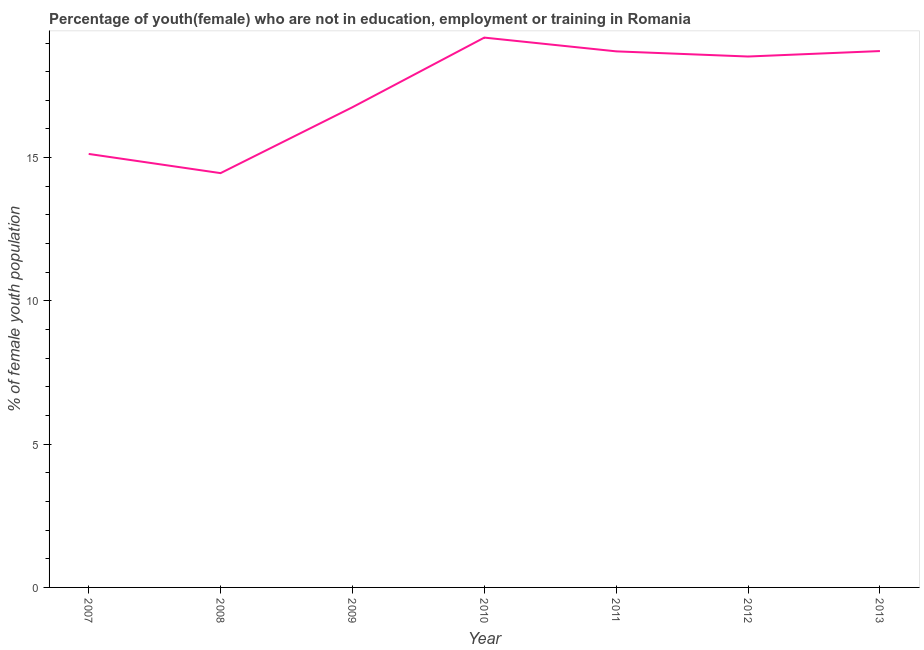What is the unemployed female youth population in 2008?
Make the answer very short. 14.46. Across all years, what is the maximum unemployed female youth population?
Provide a succinct answer. 19.19. Across all years, what is the minimum unemployed female youth population?
Your answer should be compact. 14.46. In which year was the unemployed female youth population maximum?
Your answer should be compact. 2010. What is the sum of the unemployed female youth population?
Your answer should be very brief. 121.5. What is the difference between the unemployed female youth population in 2007 and 2011?
Offer a terse response. -3.58. What is the average unemployed female youth population per year?
Your answer should be very brief. 17.36. What is the median unemployed female youth population?
Offer a very short reply. 18.53. What is the ratio of the unemployed female youth population in 2007 to that in 2009?
Your answer should be compact. 0.9. What is the difference between the highest and the second highest unemployed female youth population?
Give a very brief answer. 0.47. Is the sum of the unemployed female youth population in 2009 and 2011 greater than the maximum unemployed female youth population across all years?
Offer a very short reply. Yes. What is the difference between the highest and the lowest unemployed female youth population?
Keep it short and to the point. 4.73. Does the unemployed female youth population monotonically increase over the years?
Your response must be concise. No. How many years are there in the graph?
Provide a succinct answer. 7. Does the graph contain any zero values?
Provide a short and direct response. No. What is the title of the graph?
Offer a very short reply. Percentage of youth(female) who are not in education, employment or training in Romania. What is the label or title of the X-axis?
Provide a short and direct response. Year. What is the label or title of the Y-axis?
Ensure brevity in your answer.  % of female youth population. What is the % of female youth population of 2007?
Keep it short and to the point. 15.13. What is the % of female youth population of 2008?
Provide a short and direct response. 14.46. What is the % of female youth population of 2009?
Ensure brevity in your answer.  16.76. What is the % of female youth population in 2010?
Provide a succinct answer. 19.19. What is the % of female youth population in 2011?
Make the answer very short. 18.71. What is the % of female youth population of 2012?
Your answer should be compact. 18.53. What is the % of female youth population of 2013?
Make the answer very short. 18.72. What is the difference between the % of female youth population in 2007 and 2008?
Offer a terse response. 0.67. What is the difference between the % of female youth population in 2007 and 2009?
Make the answer very short. -1.63. What is the difference between the % of female youth population in 2007 and 2010?
Provide a short and direct response. -4.06. What is the difference between the % of female youth population in 2007 and 2011?
Your answer should be compact. -3.58. What is the difference between the % of female youth population in 2007 and 2012?
Give a very brief answer. -3.4. What is the difference between the % of female youth population in 2007 and 2013?
Your response must be concise. -3.59. What is the difference between the % of female youth population in 2008 and 2010?
Keep it short and to the point. -4.73. What is the difference between the % of female youth population in 2008 and 2011?
Make the answer very short. -4.25. What is the difference between the % of female youth population in 2008 and 2012?
Make the answer very short. -4.07. What is the difference between the % of female youth population in 2008 and 2013?
Make the answer very short. -4.26. What is the difference between the % of female youth population in 2009 and 2010?
Your answer should be very brief. -2.43. What is the difference between the % of female youth population in 2009 and 2011?
Provide a short and direct response. -1.95. What is the difference between the % of female youth population in 2009 and 2012?
Give a very brief answer. -1.77. What is the difference between the % of female youth population in 2009 and 2013?
Your answer should be compact. -1.96. What is the difference between the % of female youth population in 2010 and 2011?
Your answer should be very brief. 0.48. What is the difference between the % of female youth population in 2010 and 2012?
Give a very brief answer. 0.66. What is the difference between the % of female youth population in 2010 and 2013?
Provide a short and direct response. 0.47. What is the difference between the % of female youth population in 2011 and 2012?
Your answer should be very brief. 0.18. What is the difference between the % of female youth population in 2011 and 2013?
Your answer should be compact. -0.01. What is the difference between the % of female youth population in 2012 and 2013?
Offer a terse response. -0.19. What is the ratio of the % of female youth population in 2007 to that in 2008?
Your answer should be very brief. 1.05. What is the ratio of the % of female youth population in 2007 to that in 2009?
Provide a succinct answer. 0.9. What is the ratio of the % of female youth population in 2007 to that in 2010?
Your answer should be compact. 0.79. What is the ratio of the % of female youth population in 2007 to that in 2011?
Your response must be concise. 0.81. What is the ratio of the % of female youth population in 2007 to that in 2012?
Make the answer very short. 0.82. What is the ratio of the % of female youth population in 2007 to that in 2013?
Make the answer very short. 0.81. What is the ratio of the % of female youth population in 2008 to that in 2009?
Your answer should be compact. 0.86. What is the ratio of the % of female youth population in 2008 to that in 2010?
Give a very brief answer. 0.75. What is the ratio of the % of female youth population in 2008 to that in 2011?
Your answer should be very brief. 0.77. What is the ratio of the % of female youth population in 2008 to that in 2012?
Offer a terse response. 0.78. What is the ratio of the % of female youth population in 2008 to that in 2013?
Provide a succinct answer. 0.77. What is the ratio of the % of female youth population in 2009 to that in 2010?
Offer a terse response. 0.87. What is the ratio of the % of female youth population in 2009 to that in 2011?
Give a very brief answer. 0.9. What is the ratio of the % of female youth population in 2009 to that in 2012?
Your answer should be compact. 0.9. What is the ratio of the % of female youth population in 2009 to that in 2013?
Offer a terse response. 0.9. What is the ratio of the % of female youth population in 2010 to that in 2012?
Offer a very short reply. 1.04. What is the ratio of the % of female youth population in 2010 to that in 2013?
Your answer should be compact. 1.02. What is the ratio of the % of female youth population in 2011 to that in 2012?
Keep it short and to the point. 1.01. 